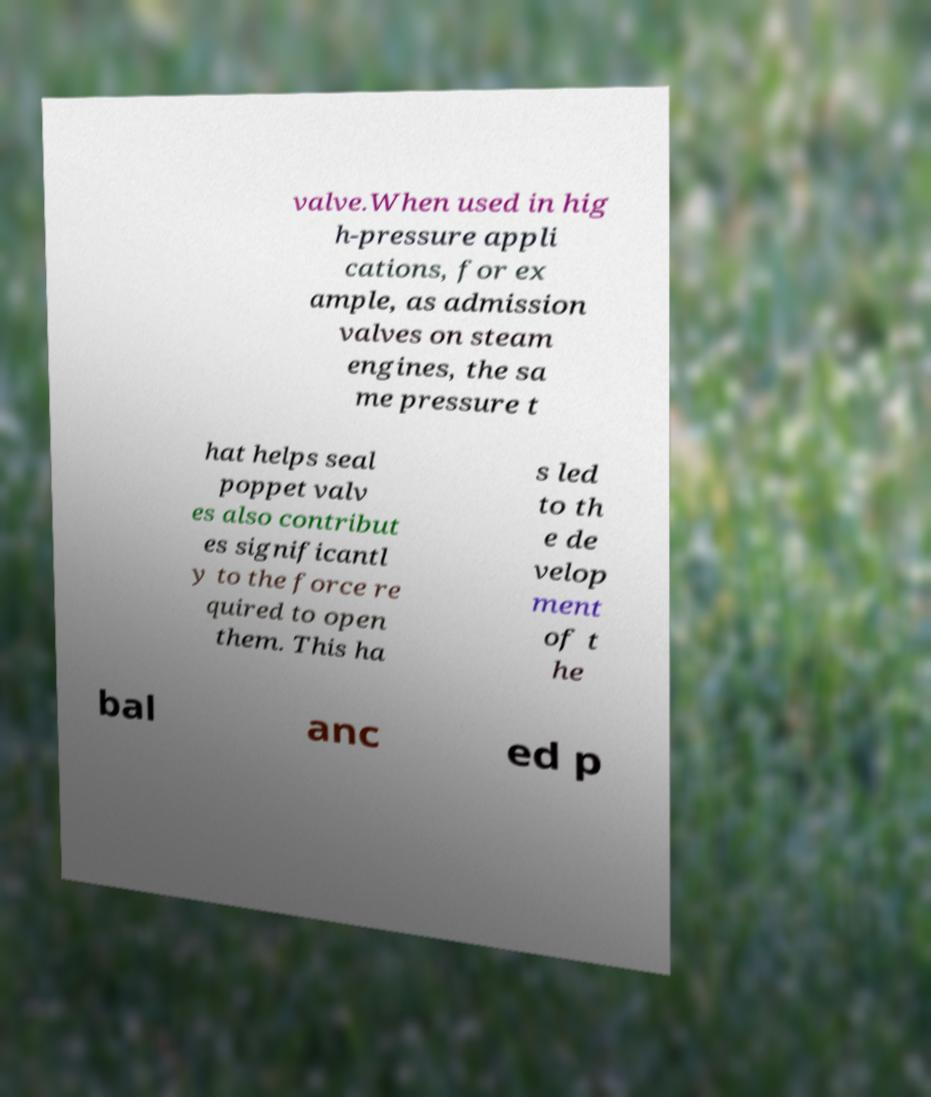Can you read and provide the text displayed in the image?This photo seems to have some interesting text. Can you extract and type it out for me? valve.When used in hig h-pressure appli cations, for ex ample, as admission valves on steam engines, the sa me pressure t hat helps seal poppet valv es also contribut es significantl y to the force re quired to open them. This ha s led to th e de velop ment of t he bal anc ed p 